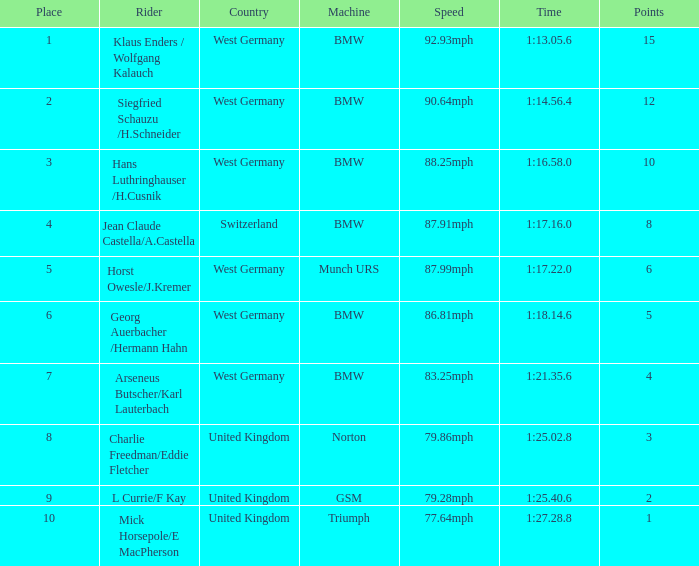Which places have points larger than 10? None. 